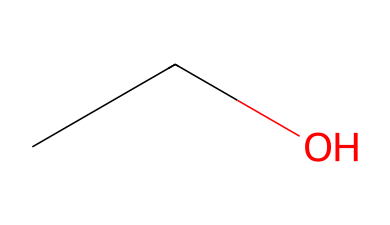What is the molecular formula of this compound? The SMILES representation "CCO" indicates there are 2 carbon (C) atoms, 6 hydrogen (H) atoms, and 1 oxygen (O) atom, leading to the formula C2H6O.
Answer: C2H6O How many carbon atoms are in ethanol? By analyzing the SMILES "CCO," we identify two carbon (C) atoms connected to each other.
Answer: 2 What type of compound is this? Ethanol, represented by "CCO," is classified as an alcohol due to the hydroxyl (-OH) group attached to the carbon chain.
Answer: alcohol How many hydrogen atoms are bonded to the carbon in ethanol? Each carbon atom in the SMILES "CCO" has sufficient hydrogen atoms to satisfy carbon's tetravalency. Thus, together, there are 6 hydrogen atoms bonded to the 2 carbon atoms.
Answer: 6 What functional group is present in ethanol? The functional group seen in the molecule represented by "CCO" is the hydroxyl (-OH) group, which is characteristic of alcohols.
Answer: hydroxyl Is ethanol an aliphatic or aromatic compound? The structure of ethanol indicated by "CCO" confirms it is aliphatic, containing only carbon chains without a benzene ring.
Answer: aliphatic 